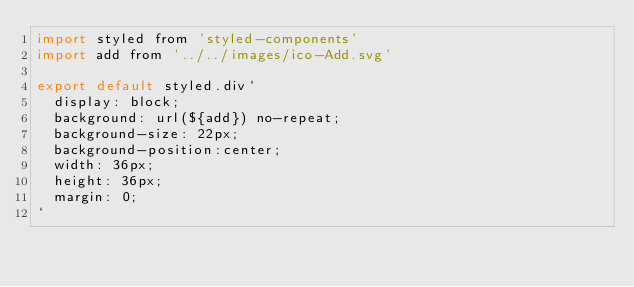Convert code to text. <code><loc_0><loc_0><loc_500><loc_500><_JavaScript_>import styled from 'styled-components'
import add from '../../images/ico-Add.svg'

export default styled.div`
  display: block;
  background: url(${add}) no-repeat;
  background-size: 22px;
  background-position:center;
  width: 36px;
  height: 36px;
  margin: 0;
`</code> 